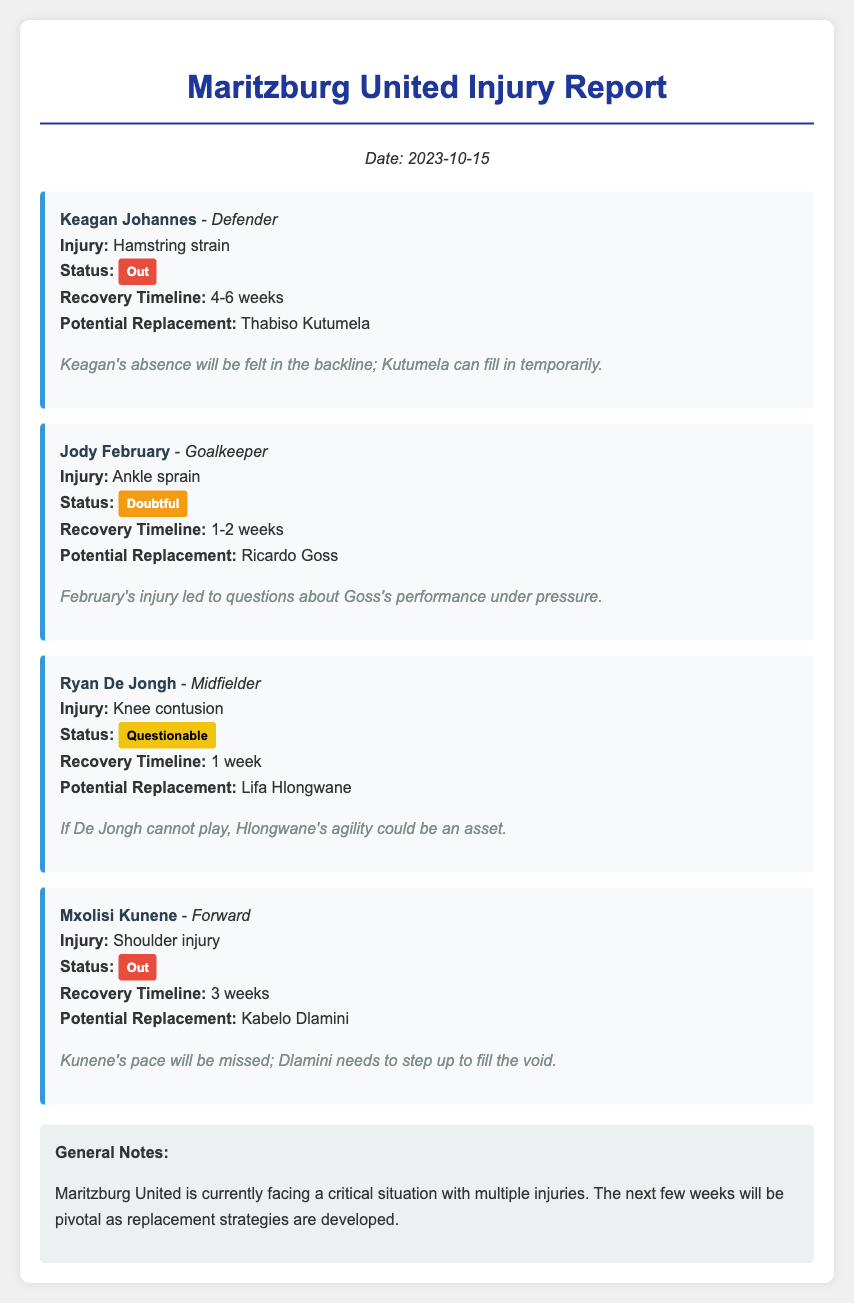What is Keagan Johannes's injury? Keagan Johannes has a hamstring strain.
Answer: Hamstring strain How long is Jody February's recovery timeline? Jody February's recovery timeline is detailed in the document as 1-2 weeks.
Answer: 1-2 weeks Who is the potential replacement for Ryan De Jongh? The document specifies that Lifa Hlongwane could be a replacement.
Answer: Lifa Hlongwane What is the status of Mxolisi Kunene's injury? The document states that Mxolisi Kunene is out due to his shoulder injury.
Answer: Out What are the general notes regarding the team's situation? The general notes highlight that the team is facing a critical situation with multiple injuries.
Answer: Critical situation with multiple injuries What is the recovery timeline for Keagan Johannes? The document indicates that Keagan Johannes's recovery timeline is 4-6 weeks.
Answer: 4-6 weeks What injury does Jody February have? Jody February's injury is an ankle sprain.
Answer: Ankle sprain Which player needs to step up in place of Mxolisi Kunene? The document mentions Kabelo Dlamini as the potential player to step up.
Answer: Kabelo Dlamini What is Ryan De Jongh's current status? Ryan De Jongh's status is labeled as questionable in the report.
Answer: Questionable 